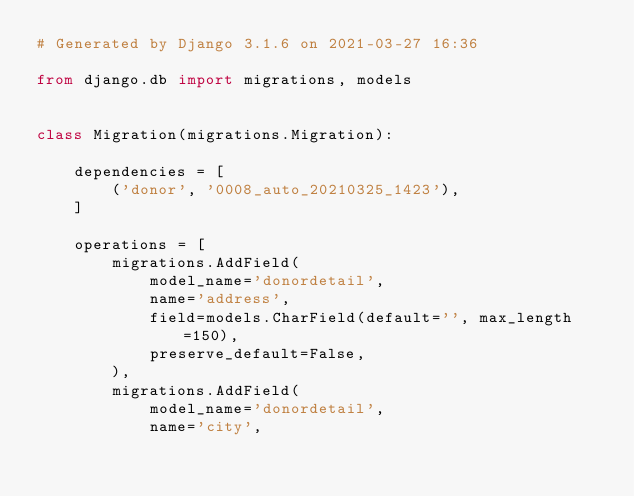<code> <loc_0><loc_0><loc_500><loc_500><_Python_># Generated by Django 3.1.6 on 2021-03-27 16:36

from django.db import migrations, models


class Migration(migrations.Migration):

    dependencies = [
        ('donor', '0008_auto_20210325_1423'),
    ]

    operations = [
        migrations.AddField(
            model_name='donordetail',
            name='address',
            field=models.CharField(default='', max_length=150),
            preserve_default=False,
        ),
        migrations.AddField(
            model_name='donordetail',
            name='city',</code> 